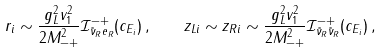Convert formula to latex. <formula><loc_0><loc_0><loc_500><loc_500>r _ { i } \sim \frac { g _ { L } ^ { 2 } v _ { 1 } ^ { 2 } } { 2 M ^ { 2 } _ { - + } } \mathcal { I } ^ { - + } _ { \tilde { \nu } _ { R } e _ { R } } ( c _ { E _ { i } } ) \, , \quad z _ { L i } \sim z _ { R i } \sim \frac { g _ { L } ^ { 2 } v _ { 1 } ^ { 2 } } { 2 M ^ { 2 } _ { - + } } \mathcal { I } ^ { - + } _ { \tilde { \nu } _ { R } \tilde { \nu } _ { R } } ( c _ { E _ { i } } ) \, ,</formula> 